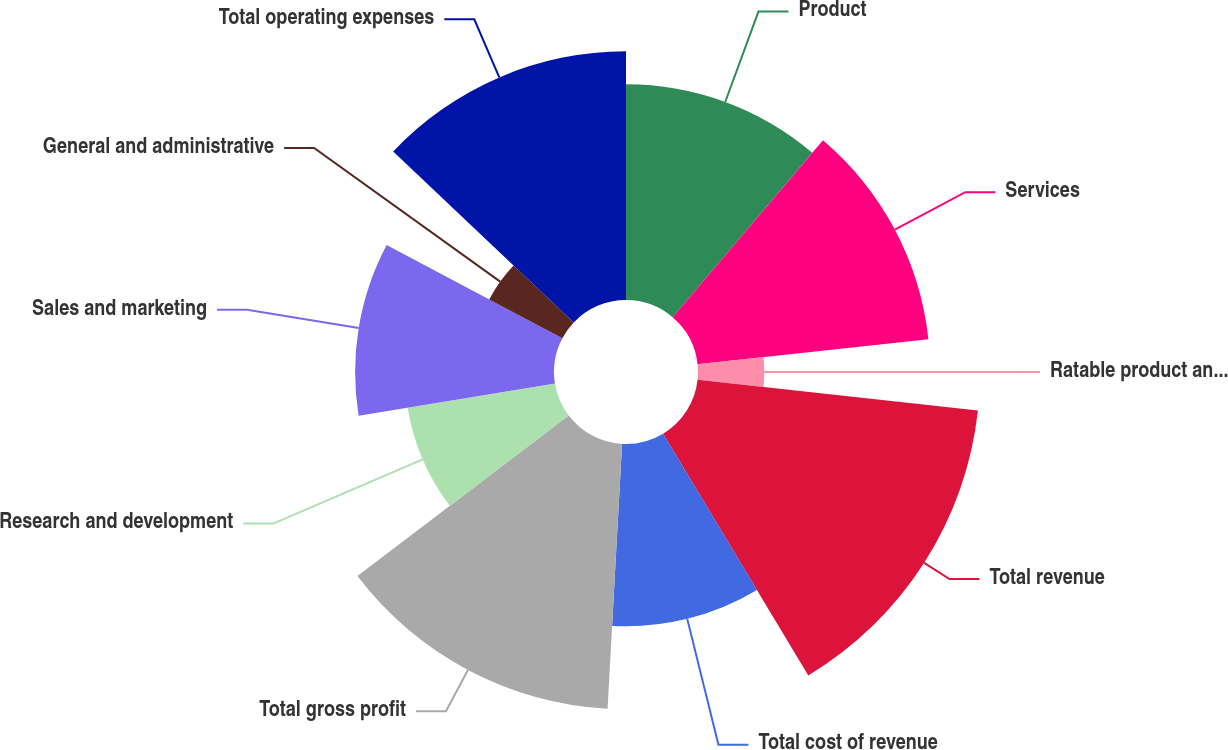Convert chart. <chart><loc_0><loc_0><loc_500><loc_500><pie_chart><fcel>Product<fcel>Services<fcel>Ratable product and services<fcel>Total revenue<fcel>Total cost of revenue<fcel>Total gross profit<fcel>Research and development<fcel>Sales and marketing<fcel>General and administrative<fcel>Total operating expenses<nl><fcel>11.21%<fcel>12.07%<fcel>3.45%<fcel>14.66%<fcel>9.48%<fcel>13.79%<fcel>7.76%<fcel>10.34%<fcel>4.31%<fcel>12.93%<nl></chart> 